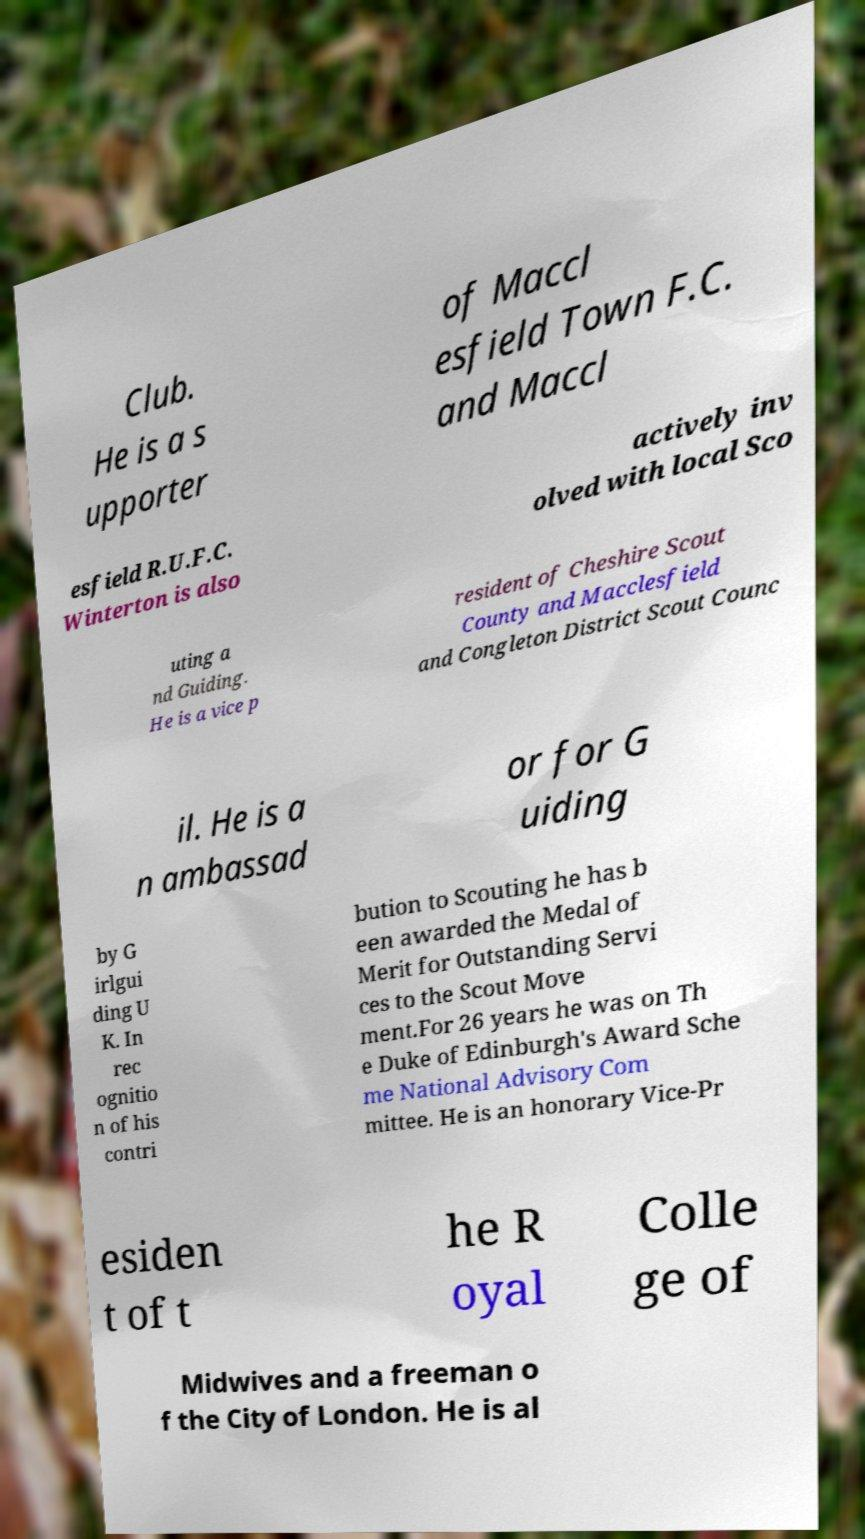There's text embedded in this image that I need extracted. Can you transcribe it verbatim? Club. He is a s upporter of Maccl esfield Town F.C. and Maccl esfield R.U.F.C. Winterton is also actively inv olved with local Sco uting a nd Guiding. He is a vice p resident of Cheshire Scout County and Macclesfield and Congleton District Scout Counc il. He is a n ambassad or for G uiding by G irlgui ding U K. In rec ognitio n of his contri bution to Scouting he has b een awarded the Medal of Merit for Outstanding Servi ces to the Scout Move ment.For 26 years he was on Th e Duke of Edinburgh's Award Sche me National Advisory Com mittee. He is an honorary Vice-Pr esiden t of t he R oyal Colle ge of Midwives and a freeman o f the City of London. He is al 